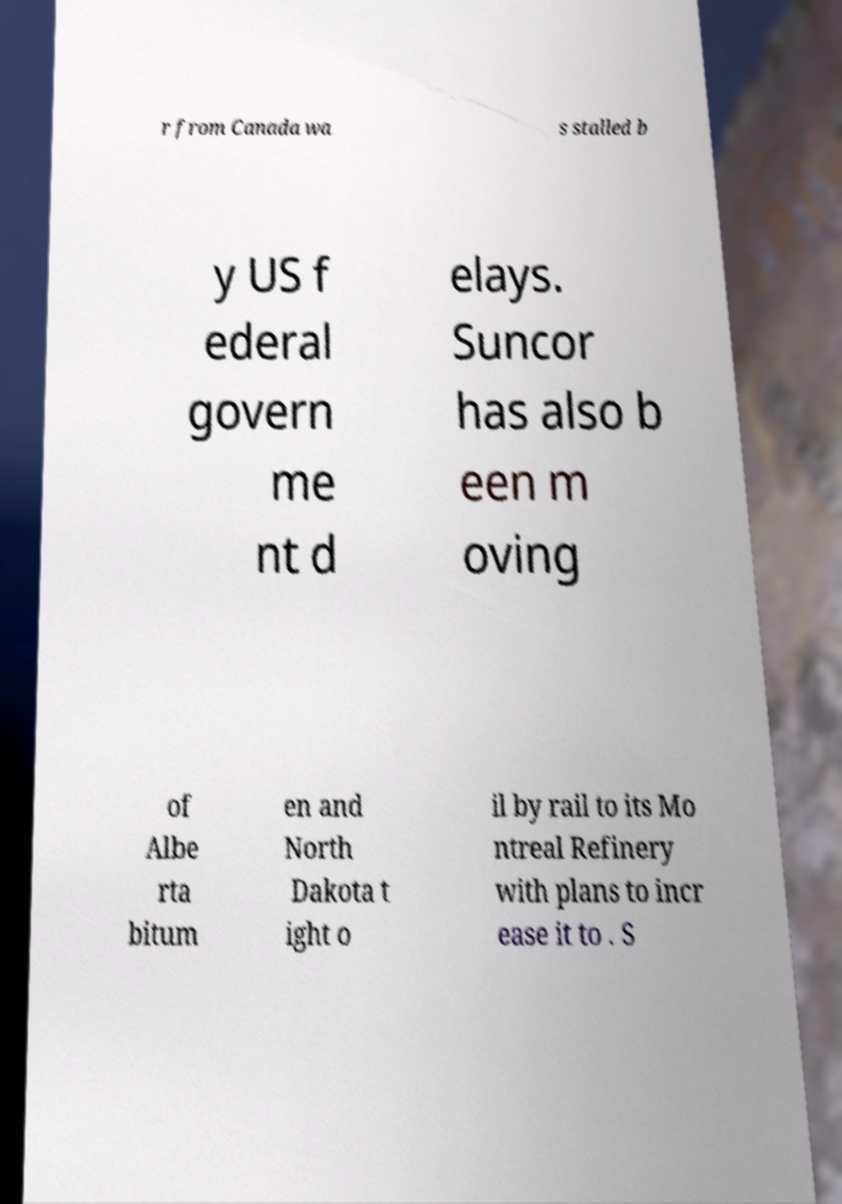I need the written content from this picture converted into text. Can you do that? r from Canada wa s stalled b y US f ederal govern me nt d elays. Suncor has also b een m oving of Albe rta bitum en and North Dakota t ight o il by rail to its Mo ntreal Refinery with plans to incr ease it to . S 